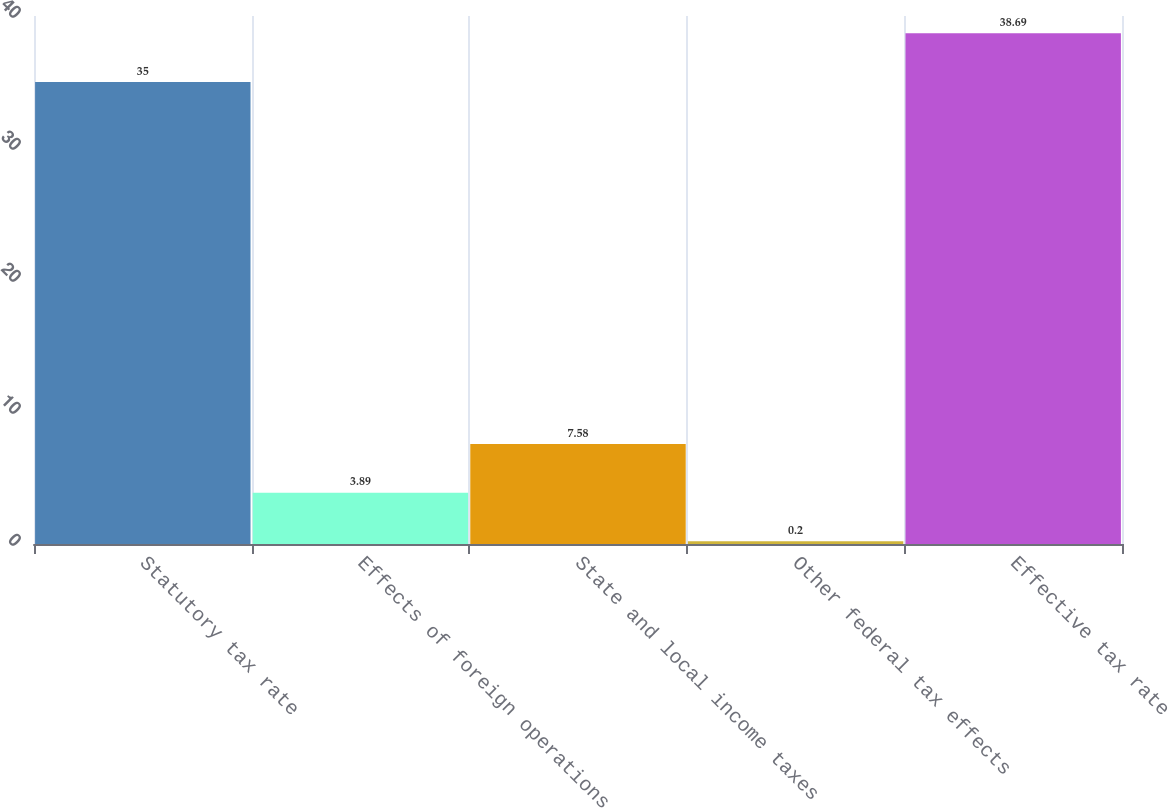<chart> <loc_0><loc_0><loc_500><loc_500><bar_chart><fcel>Statutory tax rate<fcel>Effects of foreign operations<fcel>State and local income taxes<fcel>Other federal tax effects<fcel>Effective tax rate<nl><fcel>35<fcel>3.89<fcel>7.58<fcel>0.2<fcel>38.69<nl></chart> 